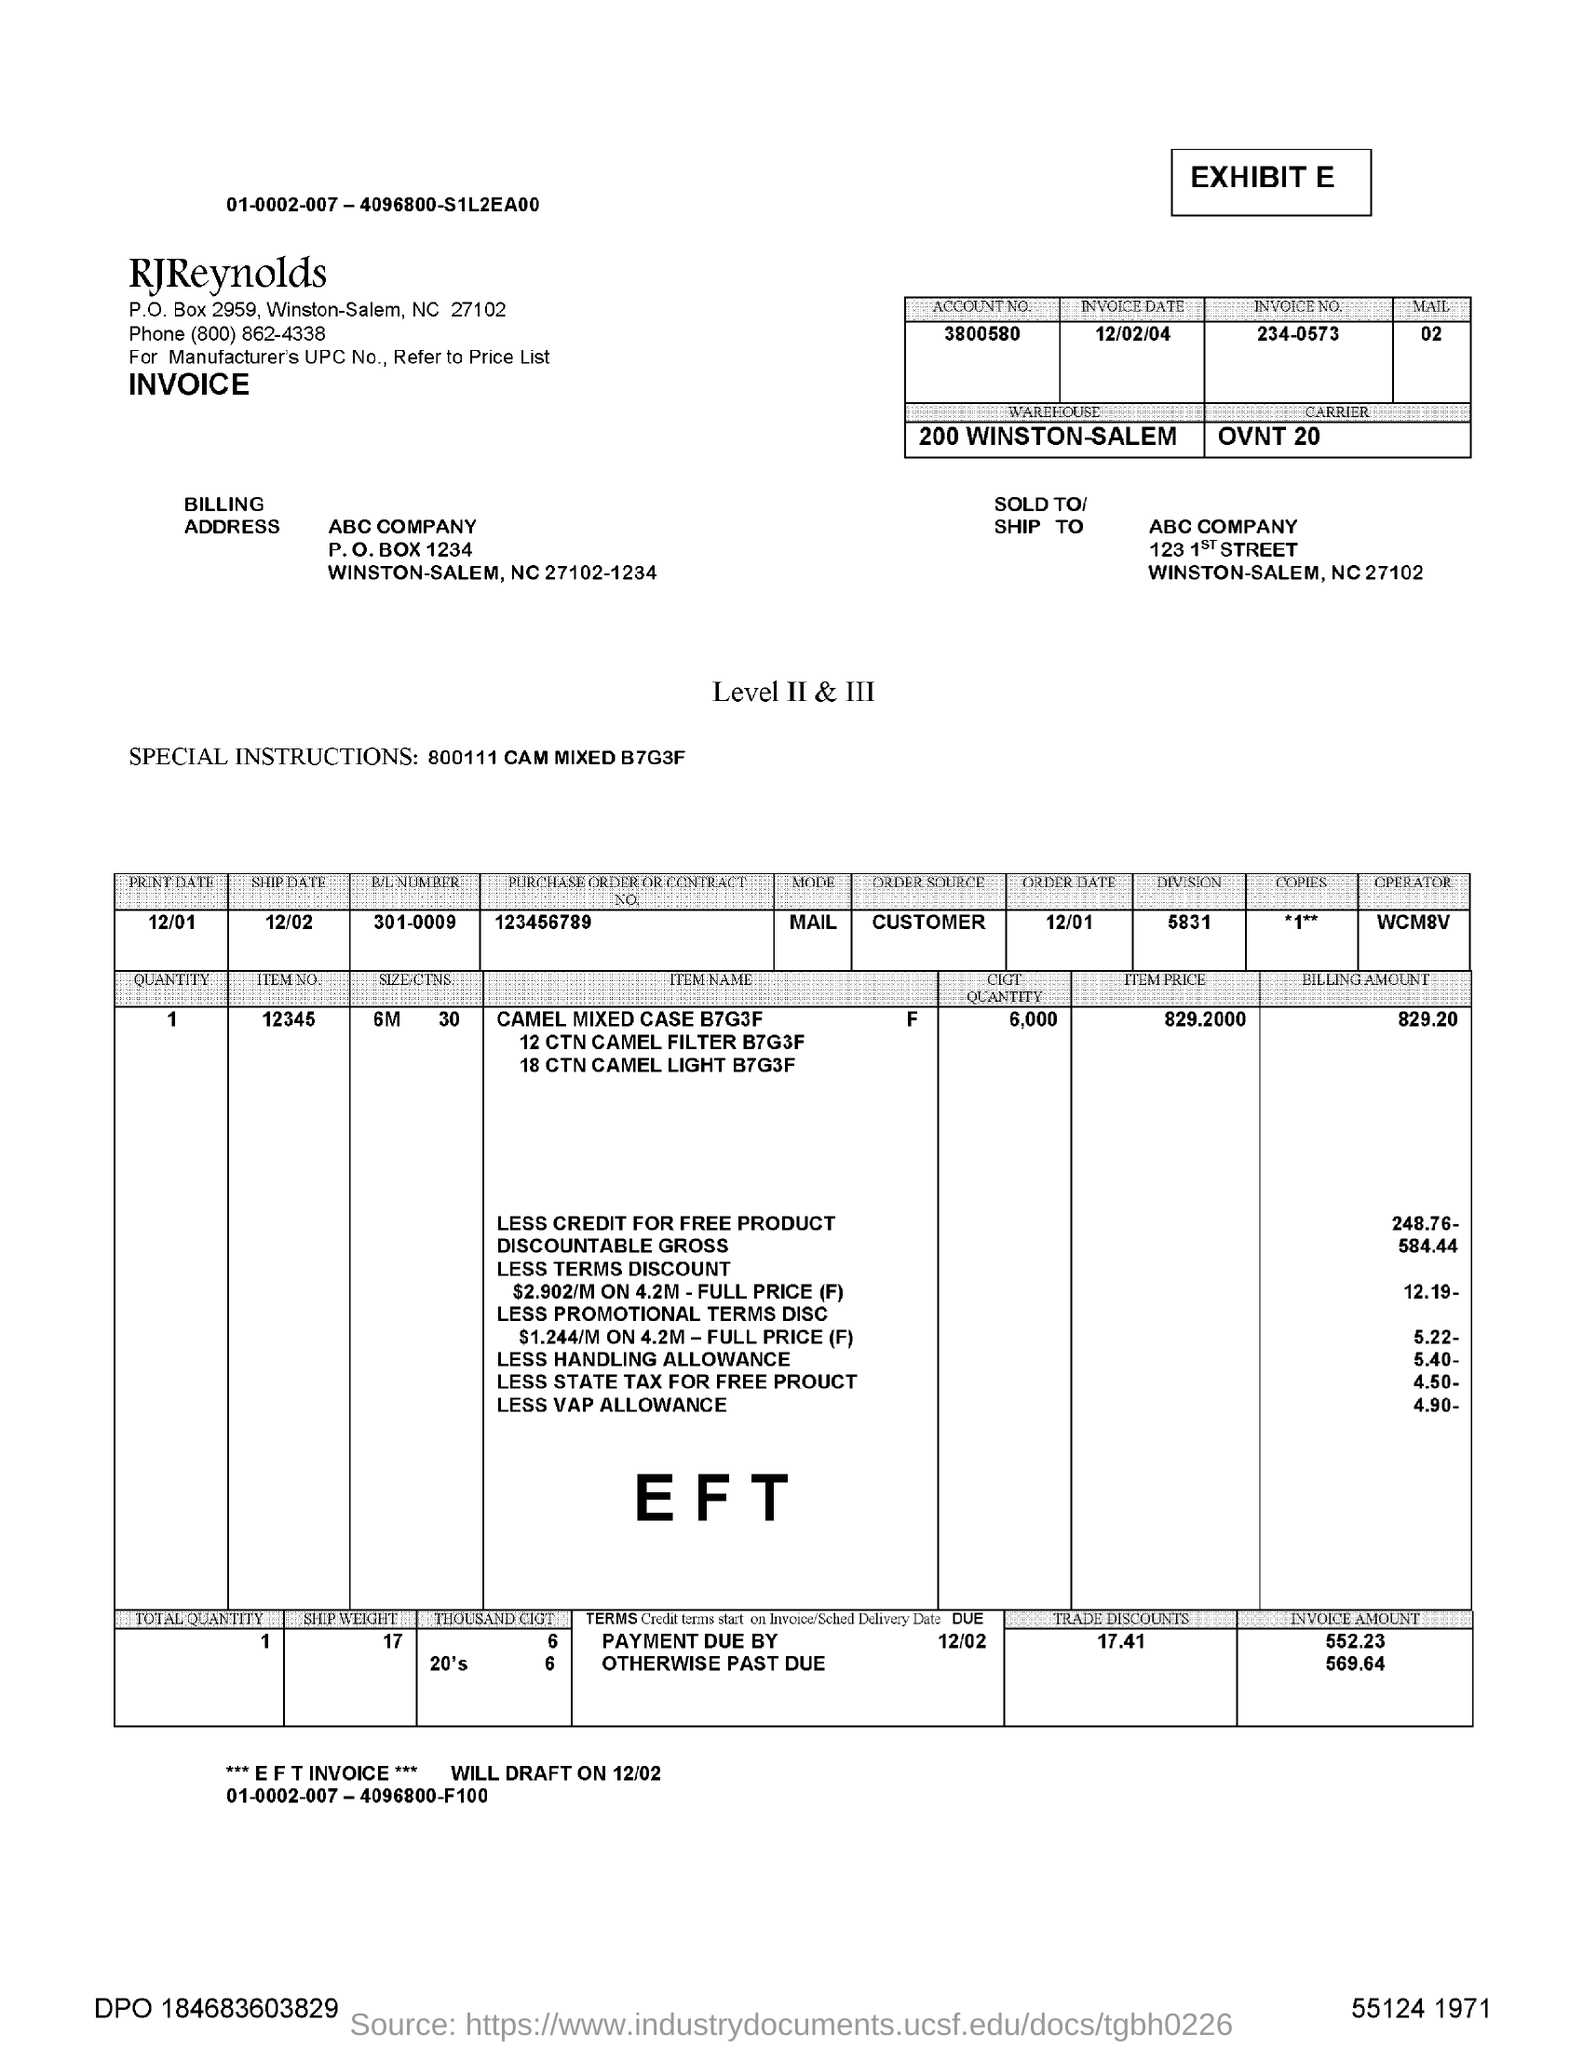What is the account number?
Offer a terse response. 3800580. What is the invoice date?
Provide a succinct answer. 12/02/04. What is the invoice number?
Provide a short and direct response. 234-0573. What is the name of the company to which this letter is being shipped to?
Your response must be concise. ABC company. What is the purchase order or contract number of the product?
Your answer should be very brief. 123456789. What is the weight of the product?
Your response must be concise. 17. Where is the warehouse?
Give a very brief answer. 200 Winston-Salem. In which mode,did the product is being send?
Your response must be concise. Mail. What is the item price of the item?
Give a very brief answer. 829.2000. What is the billing amount of the item?
Give a very brief answer. 829.20. 